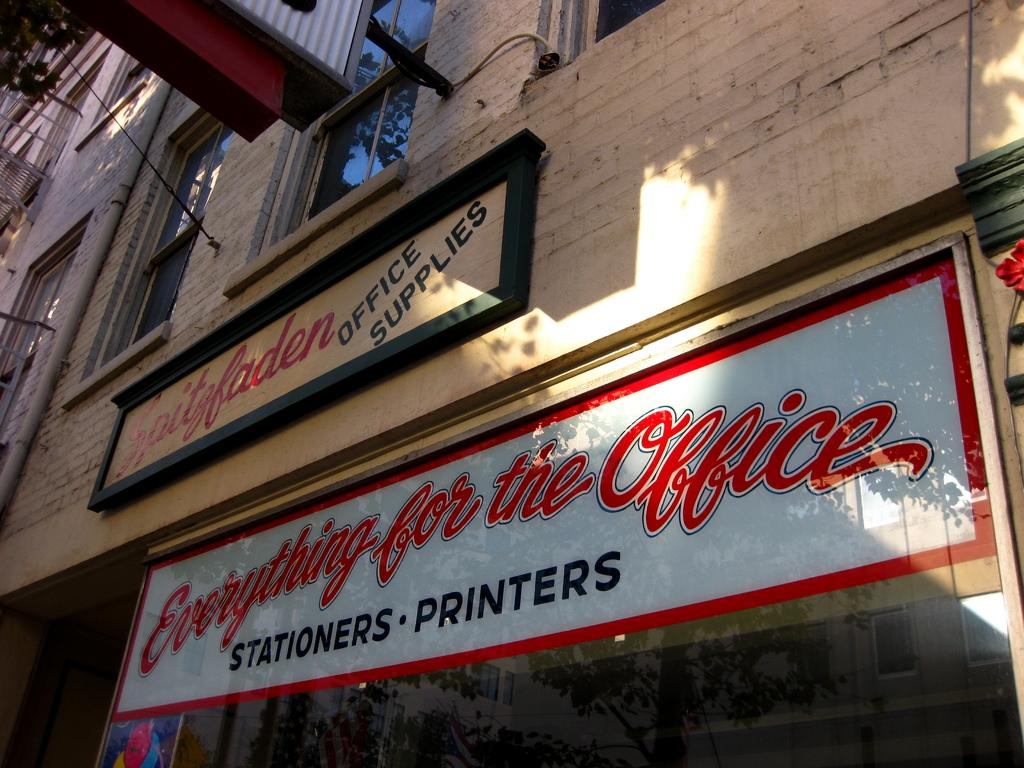What is attached to the wall of the building in the image? There are boards attached to the wall of the building. What can be seen on the building besides the boards? The building has windows. What type of vegetation is visible in the image? Leaves are visible in the top left part of the image. Can you describe the object attached to the wall? There is an object attached to the wall, but its specific nature is not clear from the image. Can you tell me how many giraffes are standing near the building in the image? There are no giraffes present in the image; it features a building with boards attached to the wall. What type of action is being performed by the knife in the image? There is no knife present in the image, so no action can be observed. 